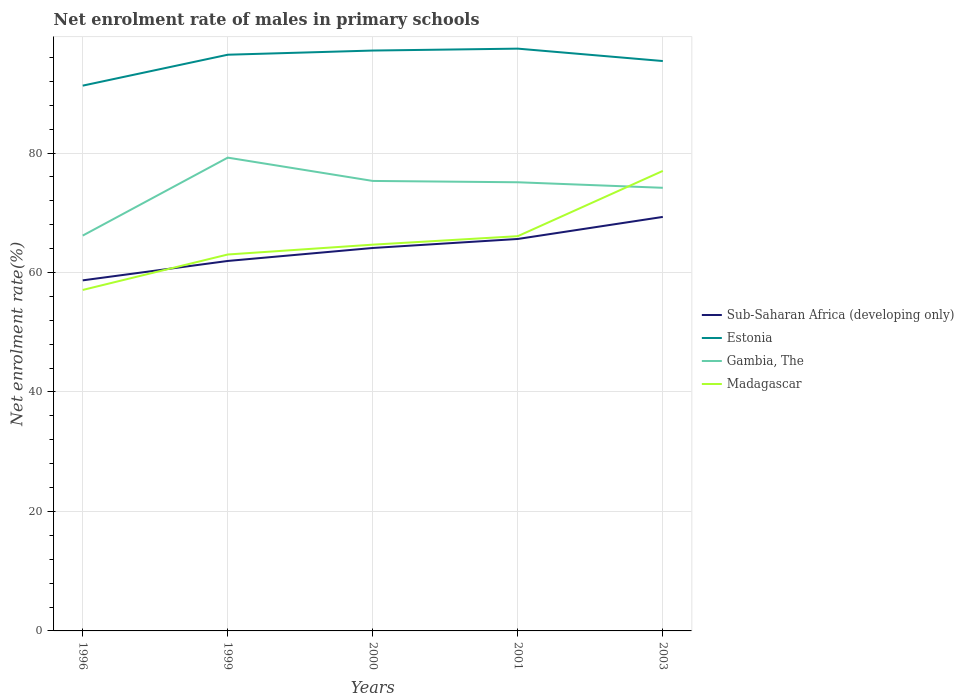How many different coloured lines are there?
Your answer should be very brief. 4. Does the line corresponding to Madagascar intersect with the line corresponding to Gambia, The?
Your response must be concise. Yes. Is the number of lines equal to the number of legend labels?
Offer a terse response. Yes. Across all years, what is the maximum net enrolment rate of males in primary schools in Estonia?
Keep it short and to the point. 91.28. What is the total net enrolment rate of males in primary schools in Estonia in the graph?
Your response must be concise. 1.76. What is the difference between the highest and the second highest net enrolment rate of males in primary schools in Madagascar?
Your answer should be compact. 19.93. What is the difference between the highest and the lowest net enrolment rate of males in primary schools in Madagascar?
Your answer should be very brief. 2. How many years are there in the graph?
Ensure brevity in your answer.  5. Are the values on the major ticks of Y-axis written in scientific E-notation?
Your response must be concise. No. Does the graph contain grids?
Offer a terse response. Yes. How are the legend labels stacked?
Keep it short and to the point. Vertical. What is the title of the graph?
Your response must be concise. Net enrolment rate of males in primary schools. What is the label or title of the Y-axis?
Your response must be concise. Net enrolment rate(%). What is the Net enrolment rate(%) of Sub-Saharan Africa (developing only) in 1996?
Your answer should be very brief. 58.69. What is the Net enrolment rate(%) in Estonia in 1996?
Ensure brevity in your answer.  91.28. What is the Net enrolment rate(%) in Gambia, The in 1996?
Give a very brief answer. 66.18. What is the Net enrolment rate(%) in Madagascar in 1996?
Provide a short and direct response. 57.08. What is the Net enrolment rate(%) of Sub-Saharan Africa (developing only) in 1999?
Ensure brevity in your answer.  61.93. What is the Net enrolment rate(%) in Estonia in 1999?
Provide a succinct answer. 96.46. What is the Net enrolment rate(%) of Gambia, The in 1999?
Give a very brief answer. 79.23. What is the Net enrolment rate(%) in Madagascar in 1999?
Your response must be concise. 63.01. What is the Net enrolment rate(%) in Sub-Saharan Africa (developing only) in 2000?
Your answer should be very brief. 64.11. What is the Net enrolment rate(%) in Estonia in 2000?
Ensure brevity in your answer.  97.16. What is the Net enrolment rate(%) of Gambia, The in 2000?
Make the answer very short. 75.33. What is the Net enrolment rate(%) in Madagascar in 2000?
Offer a very short reply. 64.66. What is the Net enrolment rate(%) in Sub-Saharan Africa (developing only) in 2001?
Keep it short and to the point. 65.61. What is the Net enrolment rate(%) of Estonia in 2001?
Offer a terse response. 97.47. What is the Net enrolment rate(%) in Gambia, The in 2001?
Provide a short and direct response. 75.11. What is the Net enrolment rate(%) in Madagascar in 2001?
Offer a very short reply. 66.08. What is the Net enrolment rate(%) in Sub-Saharan Africa (developing only) in 2003?
Your answer should be compact. 69.31. What is the Net enrolment rate(%) of Estonia in 2003?
Give a very brief answer. 95.4. What is the Net enrolment rate(%) in Gambia, The in 2003?
Your answer should be compact. 74.18. What is the Net enrolment rate(%) in Madagascar in 2003?
Offer a terse response. 77.01. Across all years, what is the maximum Net enrolment rate(%) of Sub-Saharan Africa (developing only)?
Your answer should be compact. 69.31. Across all years, what is the maximum Net enrolment rate(%) of Estonia?
Provide a succinct answer. 97.47. Across all years, what is the maximum Net enrolment rate(%) of Gambia, The?
Keep it short and to the point. 79.23. Across all years, what is the maximum Net enrolment rate(%) in Madagascar?
Provide a short and direct response. 77.01. Across all years, what is the minimum Net enrolment rate(%) of Sub-Saharan Africa (developing only)?
Provide a short and direct response. 58.69. Across all years, what is the minimum Net enrolment rate(%) of Estonia?
Your response must be concise. 91.28. Across all years, what is the minimum Net enrolment rate(%) of Gambia, The?
Your answer should be very brief. 66.18. Across all years, what is the minimum Net enrolment rate(%) in Madagascar?
Ensure brevity in your answer.  57.08. What is the total Net enrolment rate(%) of Sub-Saharan Africa (developing only) in the graph?
Provide a short and direct response. 319.64. What is the total Net enrolment rate(%) in Estonia in the graph?
Give a very brief answer. 477.77. What is the total Net enrolment rate(%) of Gambia, The in the graph?
Your response must be concise. 370.02. What is the total Net enrolment rate(%) in Madagascar in the graph?
Provide a short and direct response. 327.84. What is the difference between the Net enrolment rate(%) of Sub-Saharan Africa (developing only) in 1996 and that in 1999?
Ensure brevity in your answer.  -3.25. What is the difference between the Net enrolment rate(%) in Estonia in 1996 and that in 1999?
Provide a succinct answer. -5.18. What is the difference between the Net enrolment rate(%) in Gambia, The in 1996 and that in 1999?
Make the answer very short. -13.05. What is the difference between the Net enrolment rate(%) of Madagascar in 1996 and that in 1999?
Ensure brevity in your answer.  -5.93. What is the difference between the Net enrolment rate(%) in Sub-Saharan Africa (developing only) in 1996 and that in 2000?
Your answer should be very brief. -5.42. What is the difference between the Net enrolment rate(%) in Estonia in 1996 and that in 2000?
Make the answer very short. -5.87. What is the difference between the Net enrolment rate(%) in Gambia, The in 1996 and that in 2000?
Make the answer very short. -9.15. What is the difference between the Net enrolment rate(%) of Madagascar in 1996 and that in 2000?
Offer a terse response. -7.58. What is the difference between the Net enrolment rate(%) in Sub-Saharan Africa (developing only) in 1996 and that in 2001?
Provide a short and direct response. -6.93. What is the difference between the Net enrolment rate(%) of Estonia in 1996 and that in 2001?
Make the answer very short. -6.19. What is the difference between the Net enrolment rate(%) of Gambia, The in 1996 and that in 2001?
Your response must be concise. -8.93. What is the difference between the Net enrolment rate(%) of Madagascar in 1996 and that in 2001?
Keep it short and to the point. -9. What is the difference between the Net enrolment rate(%) of Sub-Saharan Africa (developing only) in 1996 and that in 2003?
Provide a succinct answer. -10.62. What is the difference between the Net enrolment rate(%) of Estonia in 1996 and that in 2003?
Offer a very short reply. -4.12. What is the difference between the Net enrolment rate(%) in Gambia, The in 1996 and that in 2003?
Offer a terse response. -8. What is the difference between the Net enrolment rate(%) in Madagascar in 1996 and that in 2003?
Your response must be concise. -19.93. What is the difference between the Net enrolment rate(%) in Sub-Saharan Africa (developing only) in 1999 and that in 2000?
Offer a very short reply. -2.17. What is the difference between the Net enrolment rate(%) of Estonia in 1999 and that in 2000?
Keep it short and to the point. -0.7. What is the difference between the Net enrolment rate(%) in Gambia, The in 1999 and that in 2000?
Ensure brevity in your answer.  3.9. What is the difference between the Net enrolment rate(%) in Madagascar in 1999 and that in 2000?
Your answer should be compact. -1.65. What is the difference between the Net enrolment rate(%) in Sub-Saharan Africa (developing only) in 1999 and that in 2001?
Your answer should be compact. -3.68. What is the difference between the Net enrolment rate(%) in Estonia in 1999 and that in 2001?
Give a very brief answer. -1.02. What is the difference between the Net enrolment rate(%) of Gambia, The in 1999 and that in 2001?
Provide a succinct answer. 4.12. What is the difference between the Net enrolment rate(%) in Madagascar in 1999 and that in 2001?
Offer a very short reply. -3.07. What is the difference between the Net enrolment rate(%) in Sub-Saharan Africa (developing only) in 1999 and that in 2003?
Your answer should be very brief. -7.37. What is the difference between the Net enrolment rate(%) of Estonia in 1999 and that in 2003?
Your answer should be compact. 1.06. What is the difference between the Net enrolment rate(%) of Gambia, The in 1999 and that in 2003?
Your answer should be very brief. 5.05. What is the difference between the Net enrolment rate(%) of Madagascar in 1999 and that in 2003?
Offer a very short reply. -14. What is the difference between the Net enrolment rate(%) of Sub-Saharan Africa (developing only) in 2000 and that in 2001?
Ensure brevity in your answer.  -1.51. What is the difference between the Net enrolment rate(%) in Estonia in 2000 and that in 2001?
Offer a very short reply. -0.32. What is the difference between the Net enrolment rate(%) in Gambia, The in 2000 and that in 2001?
Your answer should be compact. 0.22. What is the difference between the Net enrolment rate(%) in Madagascar in 2000 and that in 2001?
Offer a terse response. -1.42. What is the difference between the Net enrolment rate(%) of Sub-Saharan Africa (developing only) in 2000 and that in 2003?
Provide a short and direct response. -5.2. What is the difference between the Net enrolment rate(%) in Estonia in 2000 and that in 2003?
Provide a short and direct response. 1.76. What is the difference between the Net enrolment rate(%) of Gambia, The in 2000 and that in 2003?
Provide a short and direct response. 1.15. What is the difference between the Net enrolment rate(%) in Madagascar in 2000 and that in 2003?
Provide a short and direct response. -12.35. What is the difference between the Net enrolment rate(%) of Sub-Saharan Africa (developing only) in 2001 and that in 2003?
Ensure brevity in your answer.  -3.69. What is the difference between the Net enrolment rate(%) of Estonia in 2001 and that in 2003?
Ensure brevity in your answer.  2.08. What is the difference between the Net enrolment rate(%) of Gambia, The in 2001 and that in 2003?
Offer a very short reply. 0.93. What is the difference between the Net enrolment rate(%) of Madagascar in 2001 and that in 2003?
Your response must be concise. -10.93. What is the difference between the Net enrolment rate(%) of Sub-Saharan Africa (developing only) in 1996 and the Net enrolment rate(%) of Estonia in 1999?
Ensure brevity in your answer.  -37.77. What is the difference between the Net enrolment rate(%) of Sub-Saharan Africa (developing only) in 1996 and the Net enrolment rate(%) of Gambia, The in 1999?
Keep it short and to the point. -20.54. What is the difference between the Net enrolment rate(%) of Sub-Saharan Africa (developing only) in 1996 and the Net enrolment rate(%) of Madagascar in 1999?
Give a very brief answer. -4.33. What is the difference between the Net enrolment rate(%) in Estonia in 1996 and the Net enrolment rate(%) in Gambia, The in 1999?
Ensure brevity in your answer.  12.05. What is the difference between the Net enrolment rate(%) in Estonia in 1996 and the Net enrolment rate(%) in Madagascar in 1999?
Make the answer very short. 28.27. What is the difference between the Net enrolment rate(%) of Gambia, The in 1996 and the Net enrolment rate(%) of Madagascar in 1999?
Offer a terse response. 3.17. What is the difference between the Net enrolment rate(%) of Sub-Saharan Africa (developing only) in 1996 and the Net enrolment rate(%) of Estonia in 2000?
Your answer should be very brief. -38.47. What is the difference between the Net enrolment rate(%) in Sub-Saharan Africa (developing only) in 1996 and the Net enrolment rate(%) in Gambia, The in 2000?
Offer a terse response. -16.64. What is the difference between the Net enrolment rate(%) of Sub-Saharan Africa (developing only) in 1996 and the Net enrolment rate(%) of Madagascar in 2000?
Offer a very short reply. -5.97. What is the difference between the Net enrolment rate(%) in Estonia in 1996 and the Net enrolment rate(%) in Gambia, The in 2000?
Provide a short and direct response. 15.95. What is the difference between the Net enrolment rate(%) of Estonia in 1996 and the Net enrolment rate(%) of Madagascar in 2000?
Offer a very short reply. 26.62. What is the difference between the Net enrolment rate(%) in Gambia, The in 1996 and the Net enrolment rate(%) in Madagascar in 2000?
Keep it short and to the point. 1.52. What is the difference between the Net enrolment rate(%) in Sub-Saharan Africa (developing only) in 1996 and the Net enrolment rate(%) in Estonia in 2001?
Give a very brief answer. -38.79. What is the difference between the Net enrolment rate(%) in Sub-Saharan Africa (developing only) in 1996 and the Net enrolment rate(%) in Gambia, The in 2001?
Provide a short and direct response. -16.42. What is the difference between the Net enrolment rate(%) of Sub-Saharan Africa (developing only) in 1996 and the Net enrolment rate(%) of Madagascar in 2001?
Your response must be concise. -7.4. What is the difference between the Net enrolment rate(%) in Estonia in 1996 and the Net enrolment rate(%) in Gambia, The in 2001?
Provide a short and direct response. 16.17. What is the difference between the Net enrolment rate(%) of Estonia in 1996 and the Net enrolment rate(%) of Madagascar in 2001?
Ensure brevity in your answer.  25.2. What is the difference between the Net enrolment rate(%) in Gambia, The in 1996 and the Net enrolment rate(%) in Madagascar in 2001?
Offer a terse response. 0.1. What is the difference between the Net enrolment rate(%) in Sub-Saharan Africa (developing only) in 1996 and the Net enrolment rate(%) in Estonia in 2003?
Ensure brevity in your answer.  -36.71. What is the difference between the Net enrolment rate(%) of Sub-Saharan Africa (developing only) in 1996 and the Net enrolment rate(%) of Gambia, The in 2003?
Provide a short and direct response. -15.49. What is the difference between the Net enrolment rate(%) of Sub-Saharan Africa (developing only) in 1996 and the Net enrolment rate(%) of Madagascar in 2003?
Keep it short and to the point. -18.32. What is the difference between the Net enrolment rate(%) in Estonia in 1996 and the Net enrolment rate(%) in Gambia, The in 2003?
Ensure brevity in your answer.  17.1. What is the difference between the Net enrolment rate(%) of Estonia in 1996 and the Net enrolment rate(%) of Madagascar in 2003?
Your answer should be very brief. 14.27. What is the difference between the Net enrolment rate(%) of Gambia, The in 1996 and the Net enrolment rate(%) of Madagascar in 2003?
Ensure brevity in your answer.  -10.83. What is the difference between the Net enrolment rate(%) of Sub-Saharan Africa (developing only) in 1999 and the Net enrolment rate(%) of Estonia in 2000?
Provide a short and direct response. -35.22. What is the difference between the Net enrolment rate(%) of Sub-Saharan Africa (developing only) in 1999 and the Net enrolment rate(%) of Gambia, The in 2000?
Your answer should be very brief. -13.4. What is the difference between the Net enrolment rate(%) in Sub-Saharan Africa (developing only) in 1999 and the Net enrolment rate(%) in Madagascar in 2000?
Offer a terse response. -2.73. What is the difference between the Net enrolment rate(%) of Estonia in 1999 and the Net enrolment rate(%) of Gambia, The in 2000?
Ensure brevity in your answer.  21.13. What is the difference between the Net enrolment rate(%) of Estonia in 1999 and the Net enrolment rate(%) of Madagascar in 2000?
Ensure brevity in your answer.  31.8. What is the difference between the Net enrolment rate(%) in Gambia, The in 1999 and the Net enrolment rate(%) in Madagascar in 2000?
Your answer should be compact. 14.57. What is the difference between the Net enrolment rate(%) of Sub-Saharan Africa (developing only) in 1999 and the Net enrolment rate(%) of Estonia in 2001?
Provide a succinct answer. -35.54. What is the difference between the Net enrolment rate(%) in Sub-Saharan Africa (developing only) in 1999 and the Net enrolment rate(%) in Gambia, The in 2001?
Provide a short and direct response. -13.17. What is the difference between the Net enrolment rate(%) in Sub-Saharan Africa (developing only) in 1999 and the Net enrolment rate(%) in Madagascar in 2001?
Your response must be concise. -4.15. What is the difference between the Net enrolment rate(%) in Estonia in 1999 and the Net enrolment rate(%) in Gambia, The in 2001?
Make the answer very short. 21.35. What is the difference between the Net enrolment rate(%) of Estonia in 1999 and the Net enrolment rate(%) of Madagascar in 2001?
Make the answer very short. 30.37. What is the difference between the Net enrolment rate(%) in Gambia, The in 1999 and the Net enrolment rate(%) in Madagascar in 2001?
Your response must be concise. 13.15. What is the difference between the Net enrolment rate(%) in Sub-Saharan Africa (developing only) in 1999 and the Net enrolment rate(%) in Estonia in 2003?
Give a very brief answer. -33.47. What is the difference between the Net enrolment rate(%) in Sub-Saharan Africa (developing only) in 1999 and the Net enrolment rate(%) in Gambia, The in 2003?
Offer a terse response. -12.25. What is the difference between the Net enrolment rate(%) of Sub-Saharan Africa (developing only) in 1999 and the Net enrolment rate(%) of Madagascar in 2003?
Make the answer very short. -15.08. What is the difference between the Net enrolment rate(%) of Estonia in 1999 and the Net enrolment rate(%) of Gambia, The in 2003?
Your response must be concise. 22.28. What is the difference between the Net enrolment rate(%) in Estonia in 1999 and the Net enrolment rate(%) in Madagascar in 2003?
Offer a very short reply. 19.45. What is the difference between the Net enrolment rate(%) in Gambia, The in 1999 and the Net enrolment rate(%) in Madagascar in 2003?
Keep it short and to the point. 2.22. What is the difference between the Net enrolment rate(%) in Sub-Saharan Africa (developing only) in 2000 and the Net enrolment rate(%) in Estonia in 2001?
Provide a short and direct response. -33.37. What is the difference between the Net enrolment rate(%) of Sub-Saharan Africa (developing only) in 2000 and the Net enrolment rate(%) of Gambia, The in 2001?
Your response must be concise. -11. What is the difference between the Net enrolment rate(%) in Sub-Saharan Africa (developing only) in 2000 and the Net enrolment rate(%) in Madagascar in 2001?
Keep it short and to the point. -1.98. What is the difference between the Net enrolment rate(%) of Estonia in 2000 and the Net enrolment rate(%) of Gambia, The in 2001?
Give a very brief answer. 22.05. What is the difference between the Net enrolment rate(%) of Estonia in 2000 and the Net enrolment rate(%) of Madagascar in 2001?
Ensure brevity in your answer.  31.07. What is the difference between the Net enrolment rate(%) in Gambia, The in 2000 and the Net enrolment rate(%) in Madagascar in 2001?
Your answer should be compact. 9.25. What is the difference between the Net enrolment rate(%) of Sub-Saharan Africa (developing only) in 2000 and the Net enrolment rate(%) of Estonia in 2003?
Provide a short and direct response. -31.29. What is the difference between the Net enrolment rate(%) of Sub-Saharan Africa (developing only) in 2000 and the Net enrolment rate(%) of Gambia, The in 2003?
Your answer should be compact. -10.07. What is the difference between the Net enrolment rate(%) in Sub-Saharan Africa (developing only) in 2000 and the Net enrolment rate(%) in Madagascar in 2003?
Offer a terse response. -12.9. What is the difference between the Net enrolment rate(%) of Estonia in 2000 and the Net enrolment rate(%) of Gambia, The in 2003?
Offer a terse response. 22.98. What is the difference between the Net enrolment rate(%) in Estonia in 2000 and the Net enrolment rate(%) in Madagascar in 2003?
Your answer should be compact. 20.15. What is the difference between the Net enrolment rate(%) in Gambia, The in 2000 and the Net enrolment rate(%) in Madagascar in 2003?
Offer a very short reply. -1.68. What is the difference between the Net enrolment rate(%) of Sub-Saharan Africa (developing only) in 2001 and the Net enrolment rate(%) of Estonia in 2003?
Provide a succinct answer. -29.78. What is the difference between the Net enrolment rate(%) in Sub-Saharan Africa (developing only) in 2001 and the Net enrolment rate(%) in Gambia, The in 2003?
Offer a very short reply. -8.56. What is the difference between the Net enrolment rate(%) of Sub-Saharan Africa (developing only) in 2001 and the Net enrolment rate(%) of Madagascar in 2003?
Your answer should be very brief. -11.39. What is the difference between the Net enrolment rate(%) in Estonia in 2001 and the Net enrolment rate(%) in Gambia, The in 2003?
Make the answer very short. 23.3. What is the difference between the Net enrolment rate(%) in Estonia in 2001 and the Net enrolment rate(%) in Madagascar in 2003?
Provide a short and direct response. 20.47. What is the difference between the Net enrolment rate(%) in Gambia, The in 2001 and the Net enrolment rate(%) in Madagascar in 2003?
Ensure brevity in your answer.  -1.9. What is the average Net enrolment rate(%) in Sub-Saharan Africa (developing only) per year?
Ensure brevity in your answer.  63.93. What is the average Net enrolment rate(%) of Estonia per year?
Make the answer very short. 95.55. What is the average Net enrolment rate(%) of Gambia, The per year?
Provide a succinct answer. 74. What is the average Net enrolment rate(%) in Madagascar per year?
Give a very brief answer. 65.57. In the year 1996, what is the difference between the Net enrolment rate(%) in Sub-Saharan Africa (developing only) and Net enrolment rate(%) in Estonia?
Your answer should be compact. -32.59. In the year 1996, what is the difference between the Net enrolment rate(%) of Sub-Saharan Africa (developing only) and Net enrolment rate(%) of Gambia, The?
Ensure brevity in your answer.  -7.49. In the year 1996, what is the difference between the Net enrolment rate(%) of Sub-Saharan Africa (developing only) and Net enrolment rate(%) of Madagascar?
Make the answer very short. 1.61. In the year 1996, what is the difference between the Net enrolment rate(%) in Estonia and Net enrolment rate(%) in Gambia, The?
Make the answer very short. 25.1. In the year 1996, what is the difference between the Net enrolment rate(%) in Estonia and Net enrolment rate(%) in Madagascar?
Your answer should be very brief. 34.2. In the year 1996, what is the difference between the Net enrolment rate(%) in Gambia, The and Net enrolment rate(%) in Madagascar?
Offer a terse response. 9.1. In the year 1999, what is the difference between the Net enrolment rate(%) in Sub-Saharan Africa (developing only) and Net enrolment rate(%) in Estonia?
Provide a short and direct response. -34.52. In the year 1999, what is the difference between the Net enrolment rate(%) in Sub-Saharan Africa (developing only) and Net enrolment rate(%) in Gambia, The?
Provide a succinct answer. -17.3. In the year 1999, what is the difference between the Net enrolment rate(%) of Sub-Saharan Africa (developing only) and Net enrolment rate(%) of Madagascar?
Ensure brevity in your answer.  -1.08. In the year 1999, what is the difference between the Net enrolment rate(%) of Estonia and Net enrolment rate(%) of Gambia, The?
Your answer should be compact. 17.23. In the year 1999, what is the difference between the Net enrolment rate(%) of Estonia and Net enrolment rate(%) of Madagascar?
Your answer should be very brief. 33.44. In the year 1999, what is the difference between the Net enrolment rate(%) of Gambia, The and Net enrolment rate(%) of Madagascar?
Offer a terse response. 16.22. In the year 2000, what is the difference between the Net enrolment rate(%) of Sub-Saharan Africa (developing only) and Net enrolment rate(%) of Estonia?
Provide a succinct answer. -33.05. In the year 2000, what is the difference between the Net enrolment rate(%) of Sub-Saharan Africa (developing only) and Net enrolment rate(%) of Gambia, The?
Ensure brevity in your answer.  -11.22. In the year 2000, what is the difference between the Net enrolment rate(%) in Sub-Saharan Africa (developing only) and Net enrolment rate(%) in Madagascar?
Provide a short and direct response. -0.56. In the year 2000, what is the difference between the Net enrolment rate(%) in Estonia and Net enrolment rate(%) in Gambia, The?
Ensure brevity in your answer.  21.83. In the year 2000, what is the difference between the Net enrolment rate(%) of Estonia and Net enrolment rate(%) of Madagascar?
Make the answer very short. 32.49. In the year 2000, what is the difference between the Net enrolment rate(%) of Gambia, The and Net enrolment rate(%) of Madagascar?
Offer a very short reply. 10.67. In the year 2001, what is the difference between the Net enrolment rate(%) of Sub-Saharan Africa (developing only) and Net enrolment rate(%) of Estonia?
Your answer should be compact. -31.86. In the year 2001, what is the difference between the Net enrolment rate(%) in Sub-Saharan Africa (developing only) and Net enrolment rate(%) in Gambia, The?
Provide a short and direct response. -9.49. In the year 2001, what is the difference between the Net enrolment rate(%) in Sub-Saharan Africa (developing only) and Net enrolment rate(%) in Madagascar?
Your answer should be compact. -0.47. In the year 2001, what is the difference between the Net enrolment rate(%) in Estonia and Net enrolment rate(%) in Gambia, The?
Your answer should be very brief. 22.37. In the year 2001, what is the difference between the Net enrolment rate(%) in Estonia and Net enrolment rate(%) in Madagascar?
Your answer should be very brief. 31.39. In the year 2001, what is the difference between the Net enrolment rate(%) in Gambia, The and Net enrolment rate(%) in Madagascar?
Provide a short and direct response. 9.02. In the year 2003, what is the difference between the Net enrolment rate(%) in Sub-Saharan Africa (developing only) and Net enrolment rate(%) in Estonia?
Ensure brevity in your answer.  -26.09. In the year 2003, what is the difference between the Net enrolment rate(%) of Sub-Saharan Africa (developing only) and Net enrolment rate(%) of Gambia, The?
Offer a very short reply. -4.87. In the year 2003, what is the difference between the Net enrolment rate(%) of Sub-Saharan Africa (developing only) and Net enrolment rate(%) of Madagascar?
Offer a terse response. -7.7. In the year 2003, what is the difference between the Net enrolment rate(%) of Estonia and Net enrolment rate(%) of Gambia, The?
Give a very brief answer. 21.22. In the year 2003, what is the difference between the Net enrolment rate(%) of Estonia and Net enrolment rate(%) of Madagascar?
Offer a very short reply. 18.39. In the year 2003, what is the difference between the Net enrolment rate(%) in Gambia, The and Net enrolment rate(%) in Madagascar?
Provide a succinct answer. -2.83. What is the ratio of the Net enrolment rate(%) of Sub-Saharan Africa (developing only) in 1996 to that in 1999?
Offer a very short reply. 0.95. What is the ratio of the Net enrolment rate(%) in Estonia in 1996 to that in 1999?
Keep it short and to the point. 0.95. What is the ratio of the Net enrolment rate(%) in Gambia, The in 1996 to that in 1999?
Your answer should be compact. 0.84. What is the ratio of the Net enrolment rate(%) of Madagascar in 1996 to that in 1999?
Give a very brief answer. 0.91. What is the ratio of the Net enrolment rate(%) in Sub-Saharan Africa (developing only) in 1996 to that in 2000?
Your answer should be very brief. 0.92. What is the ratio of the Net enrolment rate(%) of Estonia in 1996 to that in 2000?
Offer a very short reply. 0.94. What is the ratio of the Net enrolment rate(%) in Gambia, The in 1996 to that in 2000?
Offer a very short reply. 0.88. What is the ratio of the Net enrolment rate(%) of Madagascar in 1996 to that in 2000?
Your answer should be very brief. 0.88. What is the ratio of the Net enrolment rate(%) of Sub-Saharan Africa (developing only) in 1996 to that in 2001?
Give a very brief answer. 0.89. What is the ratio of the Net enrolment rate(%) of Estonia in 1996 to that in 2001?
Your response must be concise. 0.94. What is the ratio of the Net enrolment rate(%) in Gambia, The in 1996 to that in 2001?
Your answer should be compact. 0.88. What is the ratio of the Net enrolment rate(%) of Madagascar in 1996 to that in 2001?
Give a very brief answer. 0.86. What is the ratio of the Net enrolment rate(%) in Sub-Saharan Africa (developing only) in 1996 to that in 2003?
Provide a succinct answer. 0.85. What is the ratio of the Net enrolment rate(%) in Estonia in 1996 to that in 2003?
Provide a succinct answer. 0.96. What is the ratio of the Net enrolment rate(%) of Gambia, The in 1996 to that in 2003?
Your answer should be compact. 0.89. What is the ratio of the Net enrolment rate(%) in Madagascar in 1996 to that in 2003?
Give a very brief answer. 0.74. What is the ratio of the Net enrolment rate(%) of Sub-Saharan Africa (developing only) in 1999 to that in 2000?
Provide a succinct answer. 0.97. What is the ratio of the Net enrolment rate(%) in Estonia in 1999 to that in 2000?
Your answer should be very brief. 0.99. What is the ratio of the Net enrolment rate(%) of Gambia, The in 1999 to that in 2000?
Ensure brevity in your answer.  1.05. What is the ratio of the Net enrolment rate(%) of Madagascar in 1999 to that in 2000?
Your answer should be very brief. 0.97. What is the ratio of the Net enrolment rate(%) of Sub-Saharan Africa (developing only) in 1999 to that in 2001?
Keep it short and to the point. 0.94. What is the ratio of the Net enrolment rate(%) in Gambia, The in 1999 to that in 2001?
Provide a succinct answer. 1.05. What is the ratio of the Net enrolment rate(%) of Madagascar in 1999 to that in 2001?
Offer a very short reply. 0.95. What is the ratio of the Net enrolment rate(%) of Sub-Saharan Africa (developing only) in 1999 to that in 2003?
Make the answer very short. 0.89. What is the ratio of the Net enrolment rate(%) in Estonia in 1999 to that in 2003?
Your response must be concise. 1.01. What is the ratio of the Net enrolment rate(%) of Gambia, The in 1999 to that in 2003?
Ensure brevity in your answer.  1.07. What is the ratio of the Net enrolment rate(%) in Madagascar in 1999 to that in 2003?
Your answer should be compact. 0.82. What is the ratio of the Net enrolment rate(%) in Gambia, The in 2000 to that in 2001?
Keep it short and to the point. 1. What is the ratio of the Net enrolment rate(%) of Madagascar in 2000 to that in 2001?
Ensure brevity in your answer.  0.98. What is the ratio of the Net enrolment rate(%) in Sub-Saharan Africa (developing only) in 2000 to that in 2003?
Your response must be concise. 0.93. What is the ratio of the Net enrolment rate(%) of Estonia in 2000 to that in 2003?
Keep it short and to the point. 1.02. What is the ratio of the Net enrolment rate(%) of Gambia, The in 2000 to that in 2003?
Make the answer very short. 1.02. What is the ratio of the Net enrolment rate(%) of Madagascar in 2000 to that in 2003?
Provide a short and direct response. 0.84. What is the ratio of the Net enrolment rate(%) in Sub-Saharan Africa (developing only) in 2001 to that in 2003?
Give a very brief answer. 0.95. What is the ratio of the Net enrolment rate(%) of Estonia in 2001 to that in 2003?
Give a very brief answer. 1.02. What is the ratio of the Net enrolment rate(%) in Gambia, The in 2001 to that in 2003?
Your answer should be compact. 1.01. What is the ratio of the Net enrolment rate(%) in Madagascar in 2001 to that in 2003?
Give a very brief answer. 0.86. What is the difference between the highest and the second highest Net enrolment rate(%) in Sub-Saharan Africa (developing only)?
Provide a short and direct response. 3.69. What is the difference between the highest and the second highest Net enrolment rate(%) in Estonia?
Your answer should be very brief. 0.32. What is the difference between the highest and the second highest Net enrolment rate(%) of Gambia, The?
Make the answer very short. 3.9. What is the difference between the highest and the second highest Net enrolment rate(%) in Madagascar?
Your answer should be very brief. 10.93. What is the difference between the highest and the lowest Net enrolment rate(%) in Sub-Saharan Africa (developing only)?
Offer a very short reply. 10.62. What is the difference between the highest and the lowest Net enrolment rate(%) in Estonia?
Keep it short and to the point. 6.19. What is the difference between the highest and the lowest Net enrolment rate(%) in Gambia, The?
Ensure brevity in your answer.  13.05. What is the difference between the highest and the lowest Net enrolment rate(%) in Madagascar?
Your answer should be compact. 19.93. 